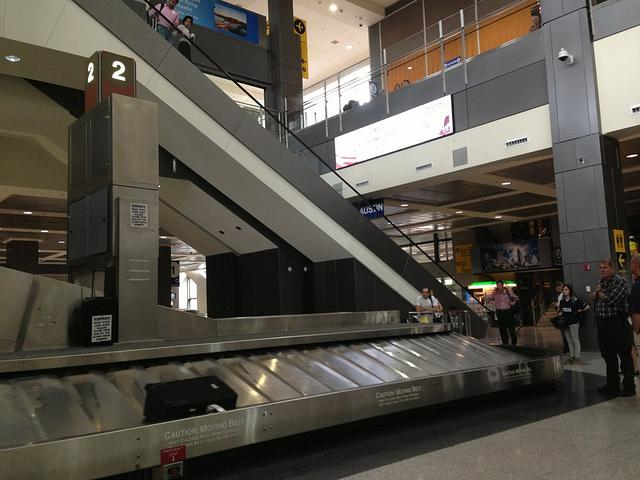What color is the suitcase on the luggage rack underneath the number two?

Choices:
A) blue
B) orange
C) black
D) red black 